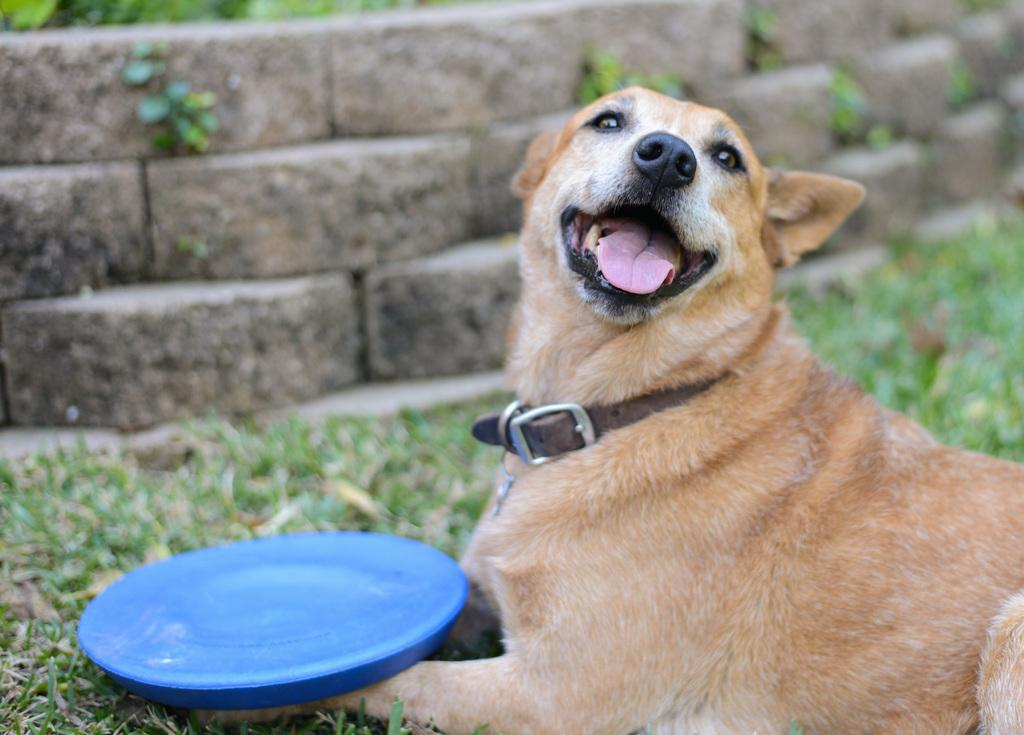What is the dog doing in the image? The dog is sitting on the grass in the image. What is placed in front of the dog? There is a plate in front of the dog. What can be seen in the background of the image? There is a wall in the background of the image. How many sisters does the dog have in the image? There are no people, including sisters, present in the image; it only features a dog sitting on the grass. 